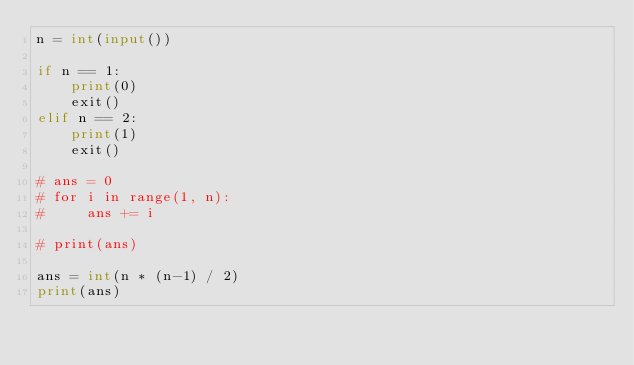Convert code to text. <code><loc_0><loc_0><loc_500><loc_500><_Python_>n = int(input())

if n == 1:
    print(0)
    exit()
elif n == 2:
    print(1)
    exit()

# ans = 0
# for i in range(1, n):
#     ans += i

# print(ans)

ans = int(n * (n-1) / 2)
print(ans)</code> 